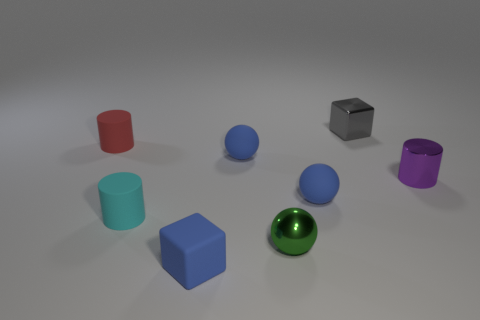What is the object that is in front of the small purple shiny cylinder and on the right side of the green sphere made of?
Ensure brevity in your answer.  Rubber. The tiny blue matte object behind the shiny thing that is on the right side of the small gray shiny block is what shape?
Provide a succinct answer. Sphere. Are there any other things that have the same color as the small matte cube?
Make the answer very short. Yes. There is a blue block; is it the same size as the sphere on the right side of the green metallic ball?
Provide a short and direct response. Yes. What number of big objects are either purple cylinders or red blocks?
Your response must be concise. 0. Is the number of small cylinders greater than the number of tiny things?
Give a very brief answer. No. There is a ball behind the small cylinder on the right side of the small green thing; how many cubes are behind it?
Make the answer very short. 1. There is a cyan matte object; what shape is it?
Your answer should be compact. Cylinder. What number of other objects are the same material as the green object?
Ensure brevity in your answer.  2. Do the green metallic thing and the metal cylinder have the same size?
Keep it short and to the point. Yes. 